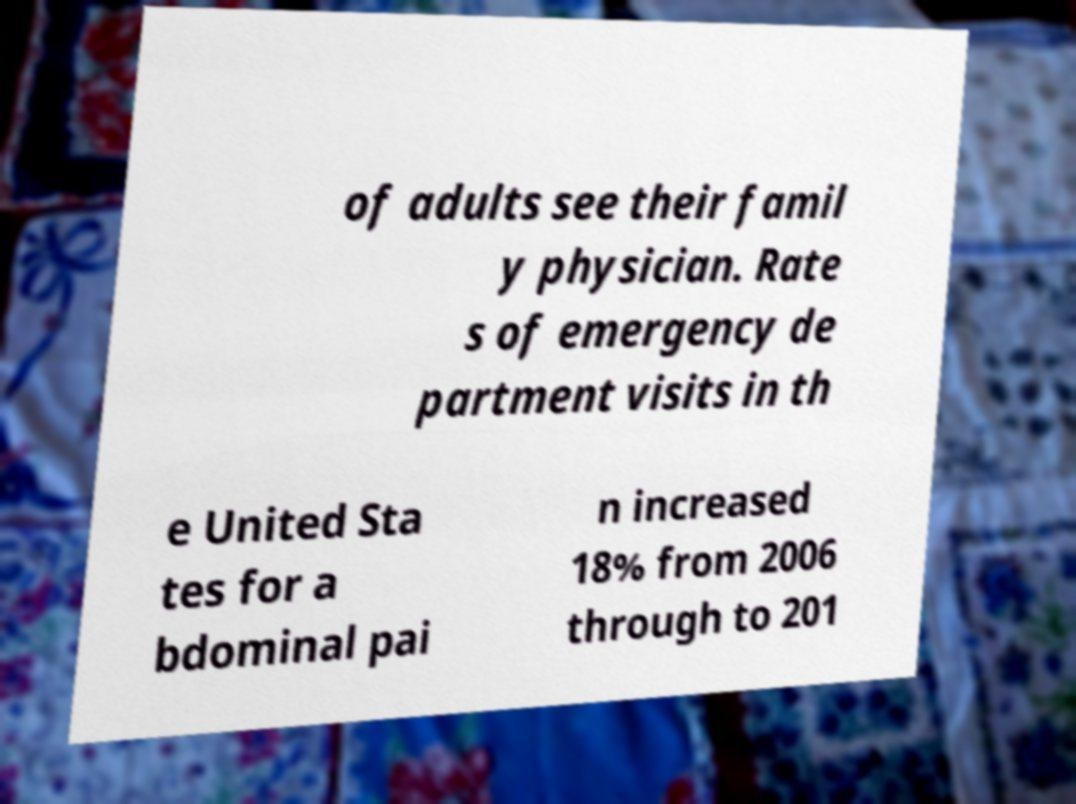I need the written content from this picture converted into text. Can you do that? of adults see their famil y physician. Rate s of emergency de partment visits in th e United Sta tes for a bdominal pai n increased 18% from 2006 through to 201 